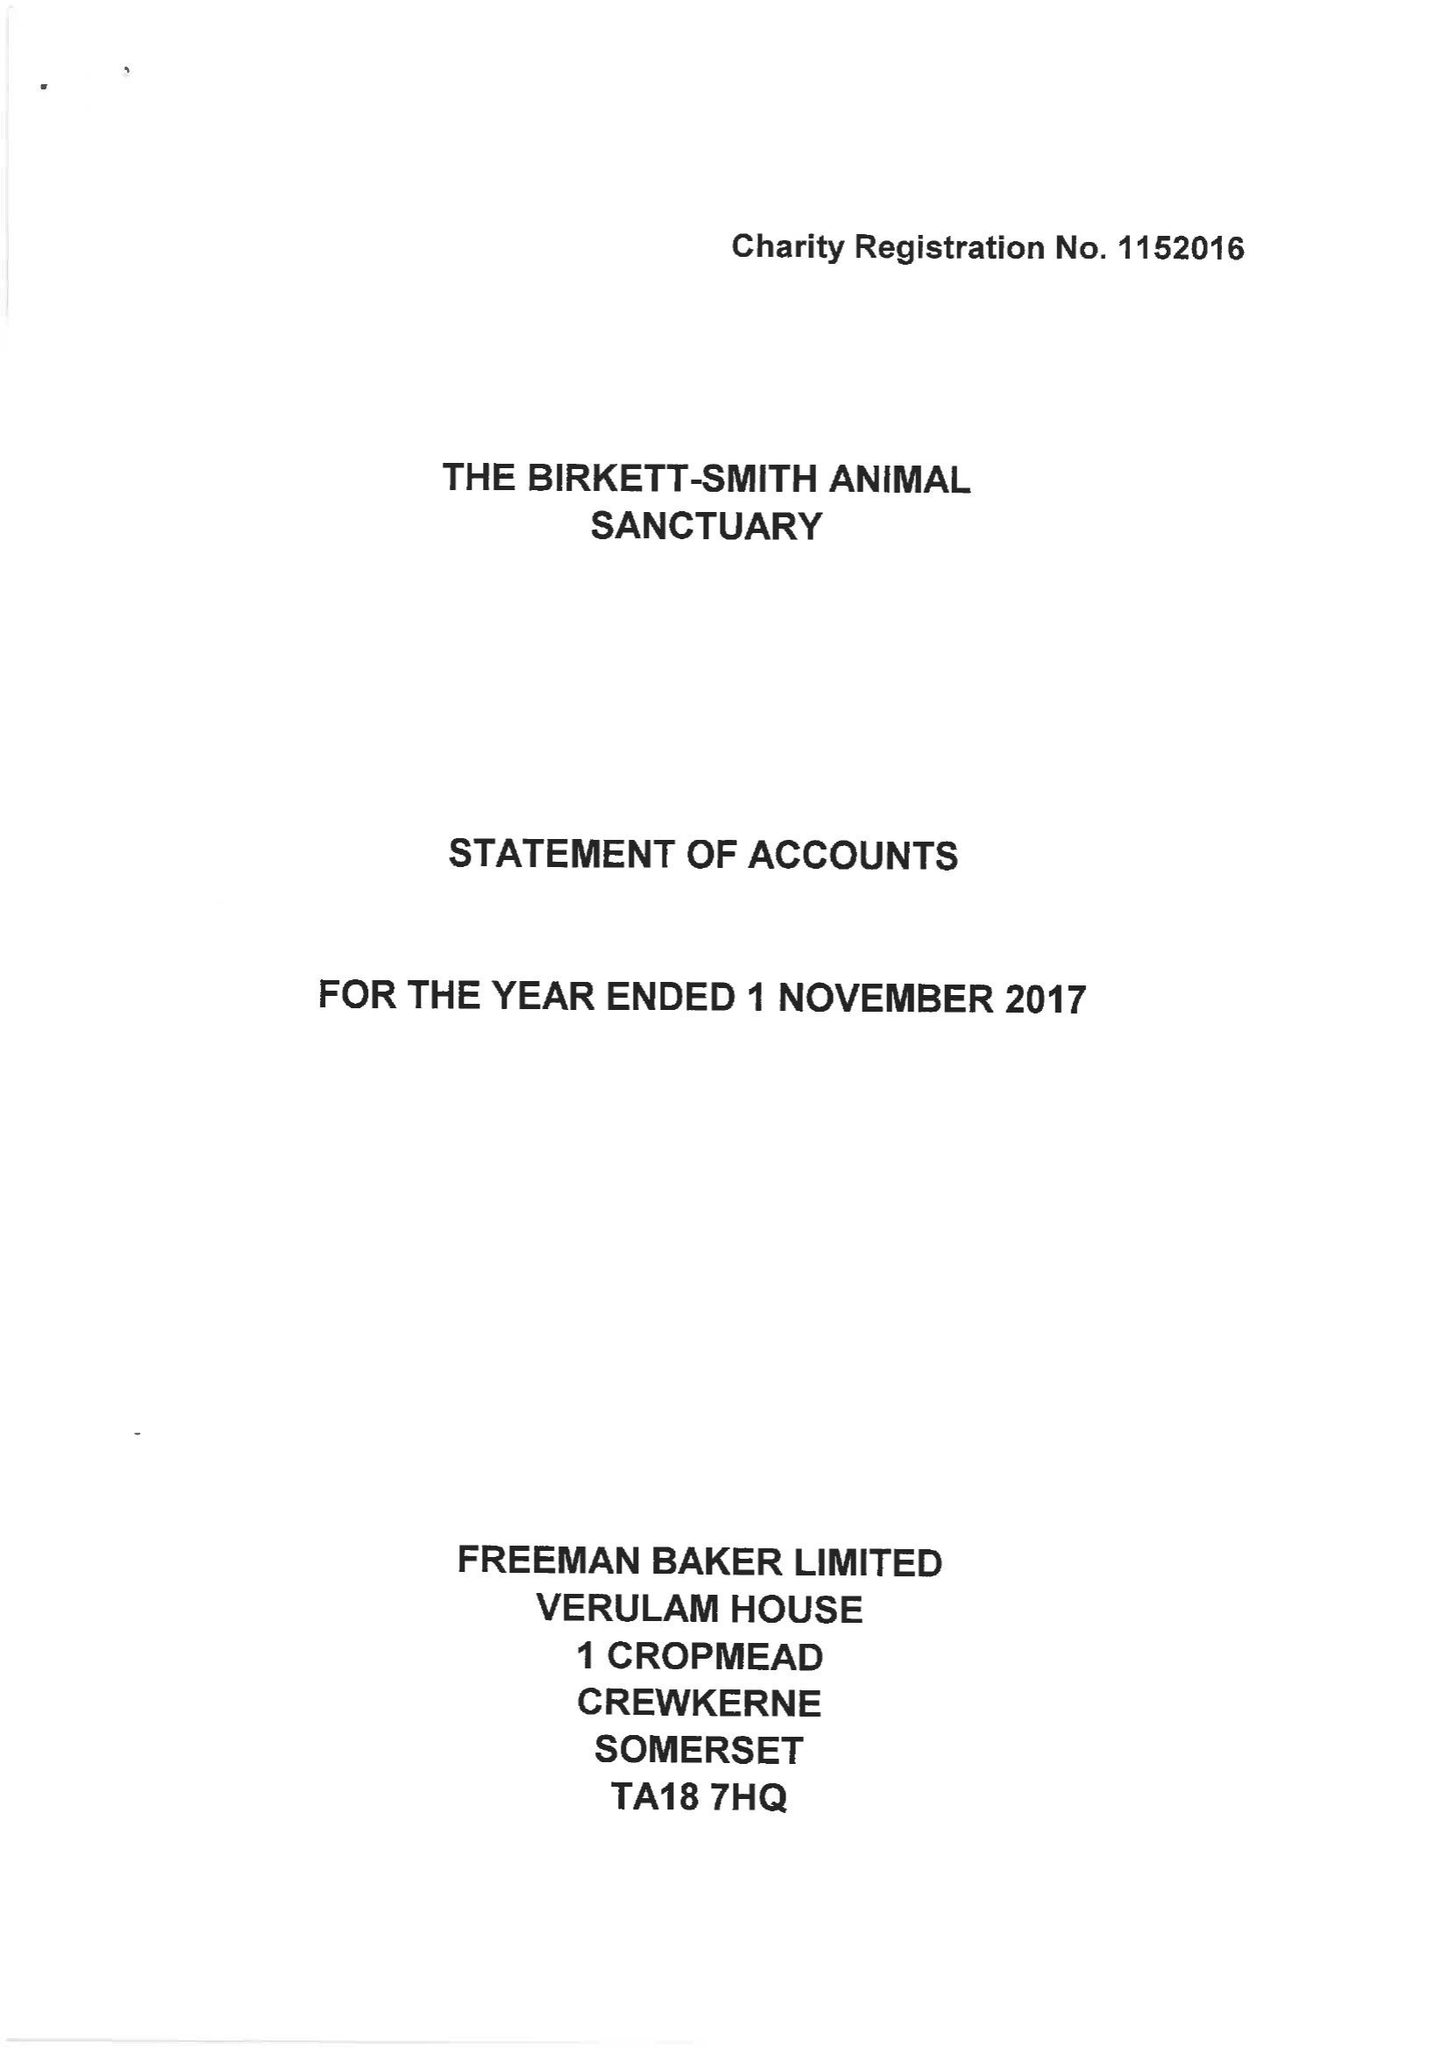What is the value for the charity_name?
Answer the question using a single word or phrase. The Birkett-Smith Animal Sanctuary 